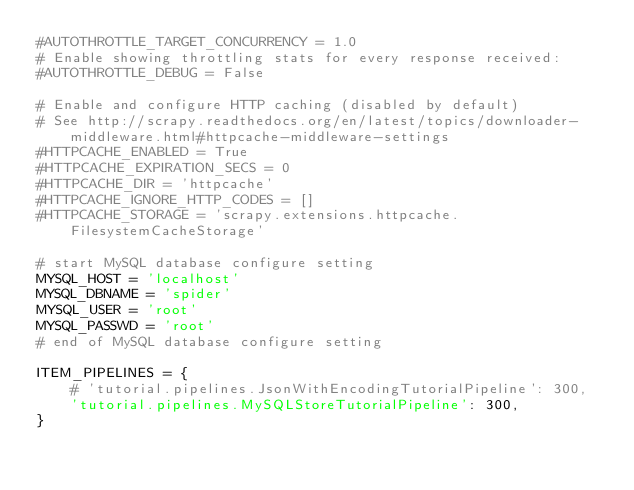Convert code to text. <code><loc_0><loc_0><loc_500><loc_500><_Python_>#AUTOTHROTTLE_TARGET_CONCURRENCY = 1.0
# Enable showing throttling stats for every response received:
#AUTOTHROTTLE_DEBUG = False

# Enable and configure HTTP caching (disabled by default)
# See http://scrapy.readthedocs.org/en/latest/topics/downloader-middleware.html#httpcache-middleware-settings
#HTTPCACHE_ENABLED = True
#HTTPCACHE_EXPIRATION_SECS = 0
#HTTPCACHE_DIR = 'httpcache'
#HTTPCACHE_IGNORE_HTTP_CODES = []
#HTTPCACHE_STORAGE = 'scrapy.extensions.httpcache.FilesystemCacheStorage'

# start MySQL database configure setting
MYSQL_HOST = 'localhost'
MYSQL_DBNAME = 'spider'
MYSQL_USER = 'root'
MYSQL_PASSWD = 'root'
# end of MySQL database configure setting

ITEM_PIPELINES = {
    # 'tutorial.pipelines.JsonWithEncodingTutorialPipeline': 300,
    'tutorial.pipelines.MySQLStoreTutorialPipeline': 300,
}
</code> 